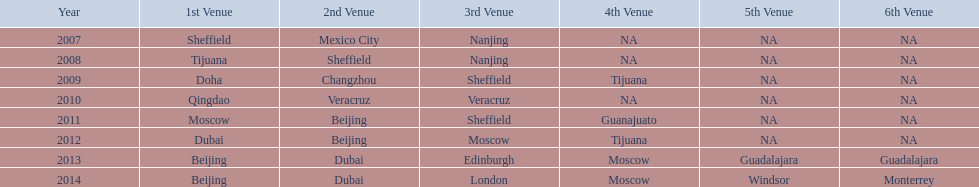Can you identify two venues that had no nations present from 2007 to 2012? 5th Venue, 6th Venue. 